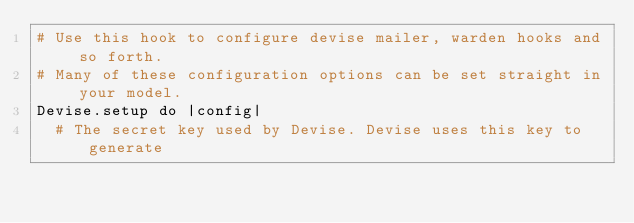<code> <loc_0><loc_0><loc_500><loc_500><_Ruby_># Use this hook to configure devise mailer, warden hooks and so forth.
# Many of these configuration options can be set straight in your model.
Devise.setup do |config|
  # The secret key used by Devise. Devise uses this key to generate</code> 